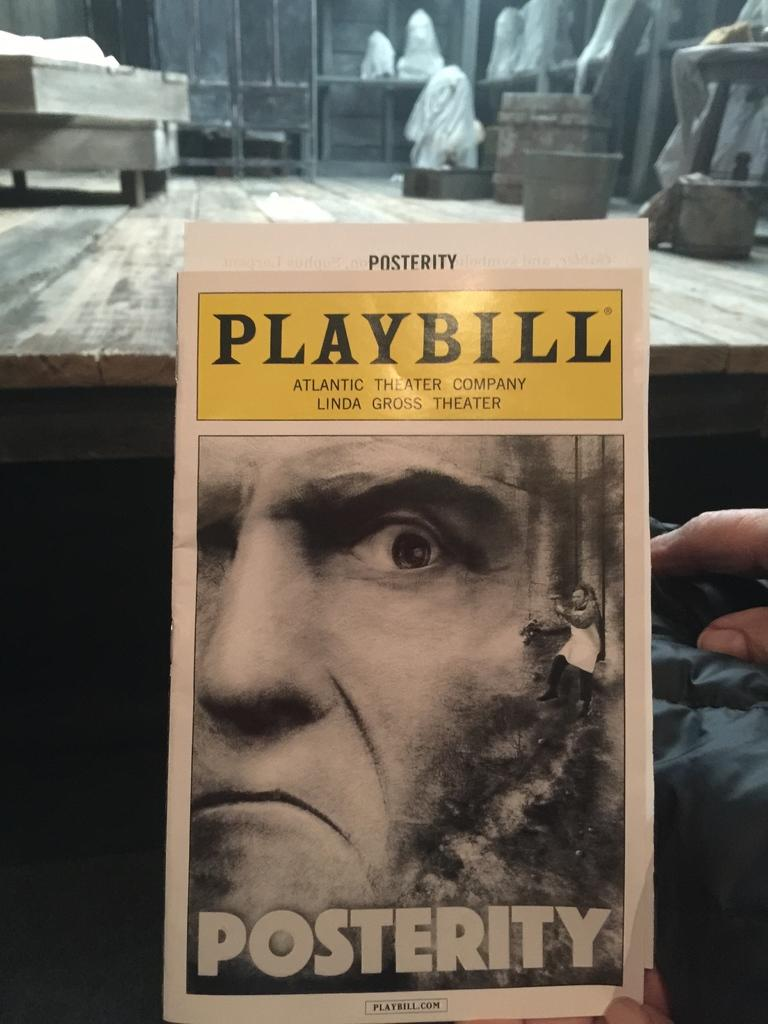<image>
Share a concise interpretation of the image provided. A playbill shows the play Posterity at the Linda Gross Theater. 